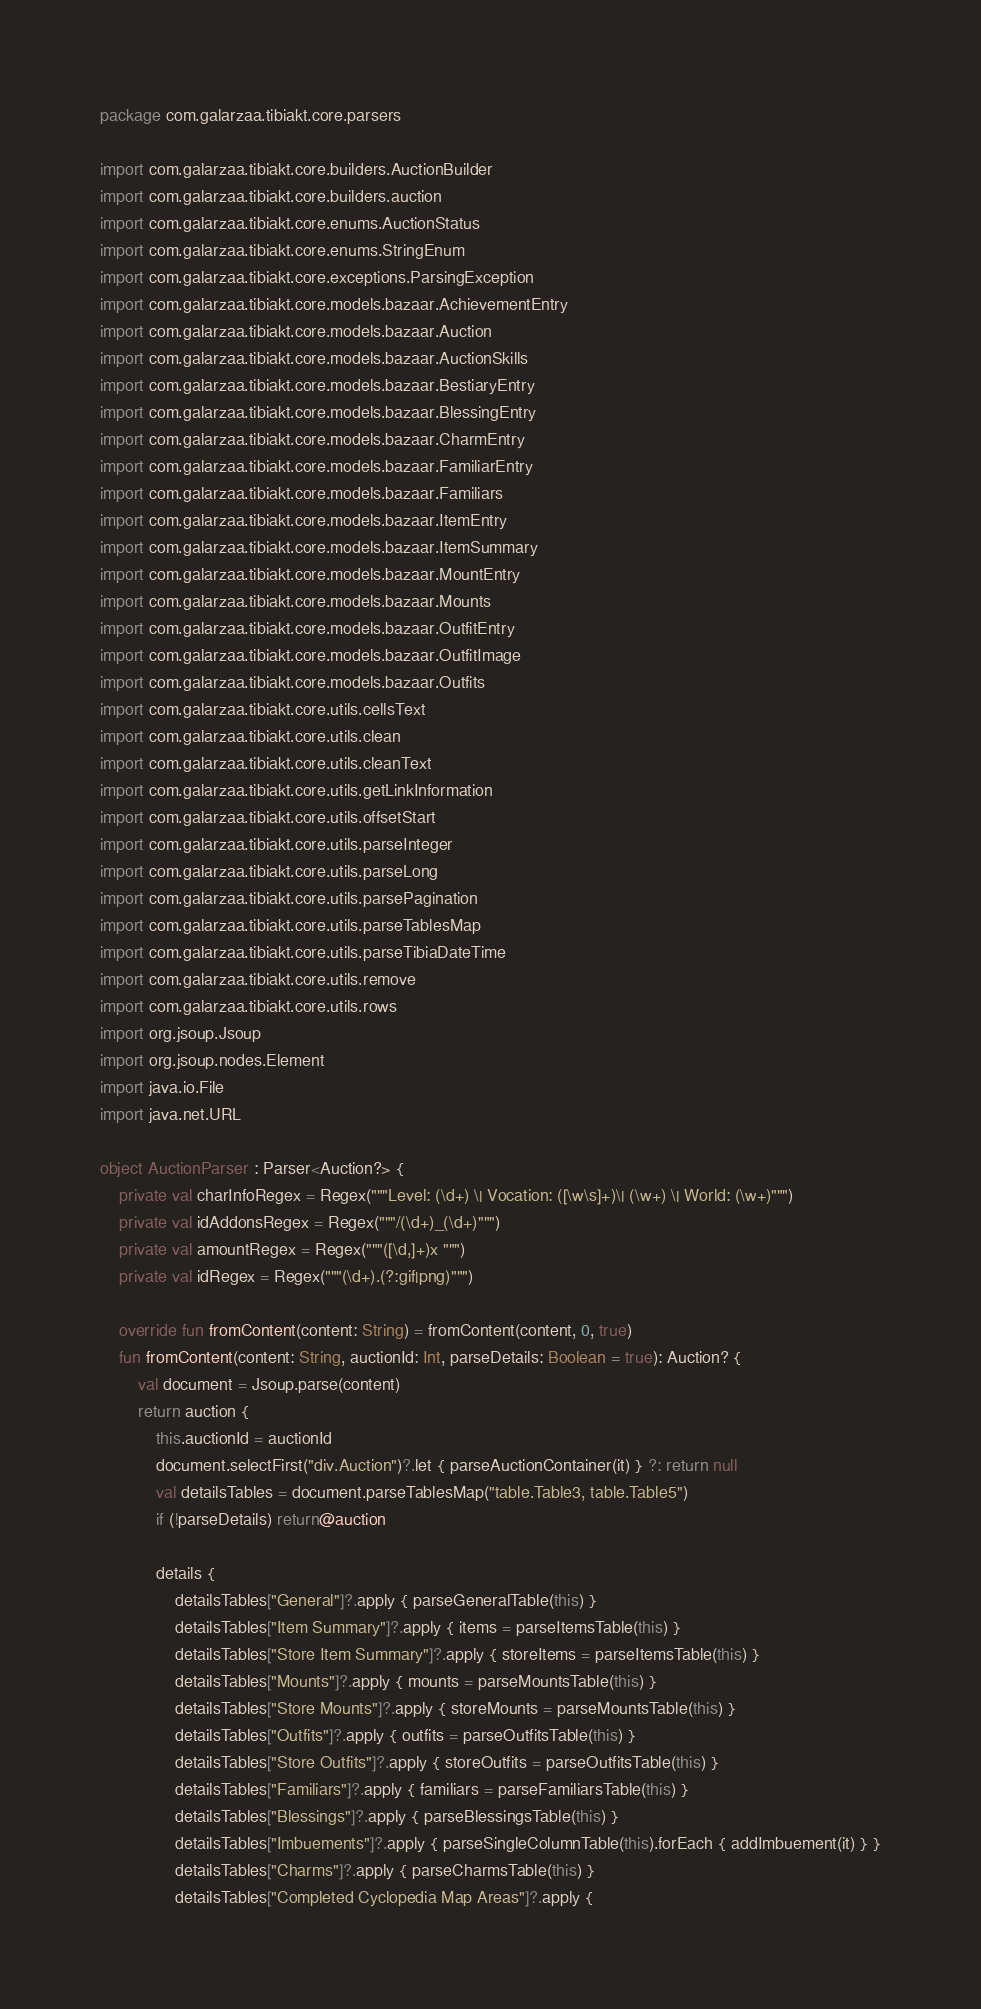Convert code to text. <code><loc_0><loc_0><loc_500><loc_500><_Kotlin_>package com.galarzaa.tibiakt.core.parsers

import com.galarzaa.tibiakt.core.builders.AuctionBuilder
import com.galarzaa.tibiakt.core.builders.auction
import com.galarzaa.tibiakt.core.enums.AuctionStatus
import com.galarzaa.tibiakt.core.enums.StringEnum
import com.galarzaa.tibiakt.core.exceptions.ParsingException
import com.galarzaa.tibiakt.core.models.bazaar.AchievementEntry
import com.galarzaa.tibiakt.core.models.bazaar.Auction
import com.galarzaa.tibiakt.core.models.bazaar.AuctionSkills
import com.galarzaa.tibiakt.core.models.bazaar.BestiaryEntry
import com.galarzaa.tibiakt.core.models.bazaar.BlessingEntry
import com.galarzaa.tibiakt.core.models.bazaar.CharmEntry
import com.galarzaa.tibiakt.core.models.bazaar.FamiliarEntry
import com.galarzaa.tibiakt.core.models.bazaar.Familiars
import com.galarzaa.tibiakt.core.models.bazaar.ItemEntry
import com.galarzaa.tibiakt.core.models.bazaar.ItemSummary
import com.galarzaa.tibiakt.core.models.bazaar.MountEntry
import com.galarzaa.tibiakt.core.models.bazaar.Mounts
import com.galarzaa.tibiakt.core.models.bazaar.OutfitEntry
import com.galarzaa.tibiakt.core.models.bazaar.OutfitImage
import com.galarzaa.tibiakt.core.models.bazaar.Outfits
import com.galarzaa.tibiakt.core.utils.cellsText
import com.galarzaa.tibiakt.core.utils.clean
import com.galarzaa.tibiakt.core.utils.cleanText
import com.galarzaa.tibiakt.core.utils.getLinkInformation
import com.galarzaa.tibiakt.core.utils.offsetStart
import com.galarzaa.tibiakt.core.utils.parseInteger
import com.galarzaa.tibiakt.core.utils.parseLong
import com.galarzaa.tibiakt.core.utils.parsePagination
import com.galarzaa.tibiakt.core.utils.parseTablesMap
import com.galarzaa.tibiakt.core.utils.parseTibiaDateTime
import com.galarzaa.tibiakt.core.utils.remove
import com.galarzaa.tibiakt.core.utils.rows
import org.jsoup.Jsoup
import org.jsoup.nodes.Element
import java.io.File
import java.net.URL

object AuctionParser : Parser<Auction?> {
    private val charInfoRegex = Regex("""Level: (\d+) \| Vocation: ([\w\s]+)\| (\w+) \| World: (\w+)""")
    private val idAddonsRegex = Regex("""/(\d+)_(\d+)""")
    private val amountRegex = Regex("""([\d,]+)x """)
    private val idRegex = Regex("""(\d+).(?:gif|png)""")

    override fun fromContent(content: String) = fromContent(content, 0, true)
    fun fromContent(content: String, auctionId: Int, parseDetails: Boolean = true): Auction? {
        val document = Jsoup.parse(content)
        return auction {
            this.auctionId = auctionId
            document.selectFirst("div.Auction")?.let { parseAuctionContainer(it) } ?: return null
            val detailsTables = document.parseTablesMap("table.Table3, table.Table5")
            if (!parseDetails) return@auction

            details {
                detailsTables["General"]?.apply { parseGeneralTable(this) }
                detailsTables["Item Summary"]?.apply { items = parseItemsTable(this) }
                detailsTables["Store Item Summary"]?.apply { storeItems = parseItemsTable(this) }
                detailsTables["Mounts"]?.apply { mounts = parseMountsTable(this) }
                detailsTables["Store Mounts"]?.apply { storeMounts = parseMountsTable(this) }
                detailsTables["Outfits"]?.apply { outfits = parseOutfitsTable(this) }
                detailsTables["Store Outfits"]?.apply { storeOutfits = parseOutfitsTable(this) }
                detailsTables["Familiars"]?.apply { familiars = parseFamiliarsTable(this) }
                detailsTables["Blessings"]?.apply { parseBlessingsTable(this) }
                detailsTables["Imbuements"]?.apply { parseSingleColumnTable(this).forEach { addImbuement(it) } }
                detailsTables["Charms"]?.apply { parseCharmsTable(this) }
                detailsTables["Completed Cyclopedia Map Areas"]?.apply {</code> 